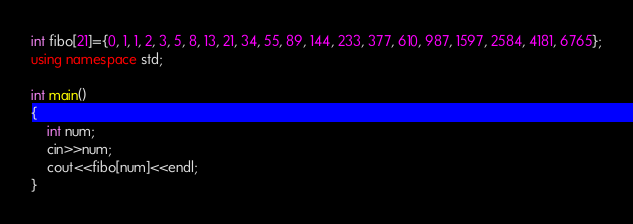Convert code to text. <code><loc_0><loc_0><loc_500><loc_500><_C++_>
int fibo[21]={0, 1, 1, 2, 3, 5, 8, 13, 21, 34, 55, 89, 144, 233, 377, 610, 987, 1597, 2584, 4181, 6765};
using namespace std;

int main()
{
	int num;
	cin>>num;
	cout<<fibo[num]<<endl;
}
</code> 